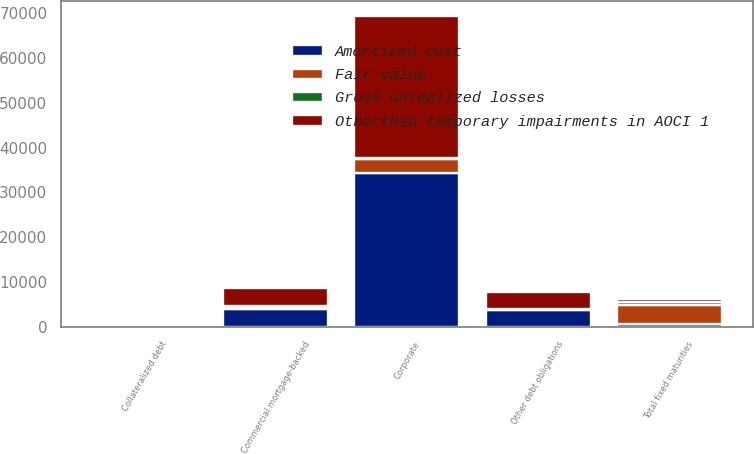<chart> <loc_0><loc_0><loc_500><loc_500><stacked_bar_chart><ecel><fcel>Corporate<fcel>Commercial mortgage-backed<fcel>Collateralized debt<fcel>Other debt obligations<fcel>Total fixed maturities<nl><fcel>Otherthan temporary impairments in AOCI 1<fcel>31615.4<fcel>4094.8<fcel>428.8<fcel>3756.9<fcel>655.1<nl><fcel>Fair value<fcel>3029.9<fcel>241.7<fcel>7<fcel>73.5<fcel>4095.1<nl><fcel>Gross unrealized losses<fcel>319.9<fcel>439.1<fcel>56.6<fcel>51.2<fcel>871.1<nl><fcel>Amortized cost<fcel>34325.4<fcel>3897.4<fcel>379.2<fcel>3779.2<fcel>655.1<nl></chart> 